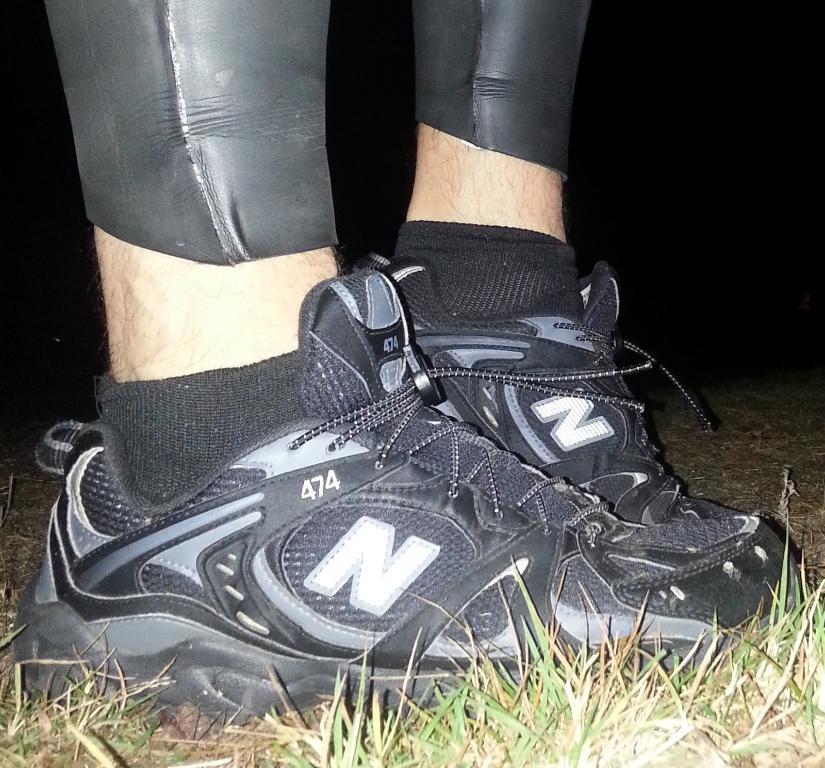In one or two sentences, can you explain what this image depicts? In this image I can see the legs of a person wearing black shoes. I can see grass at the bottom of the image and the background is dark.  